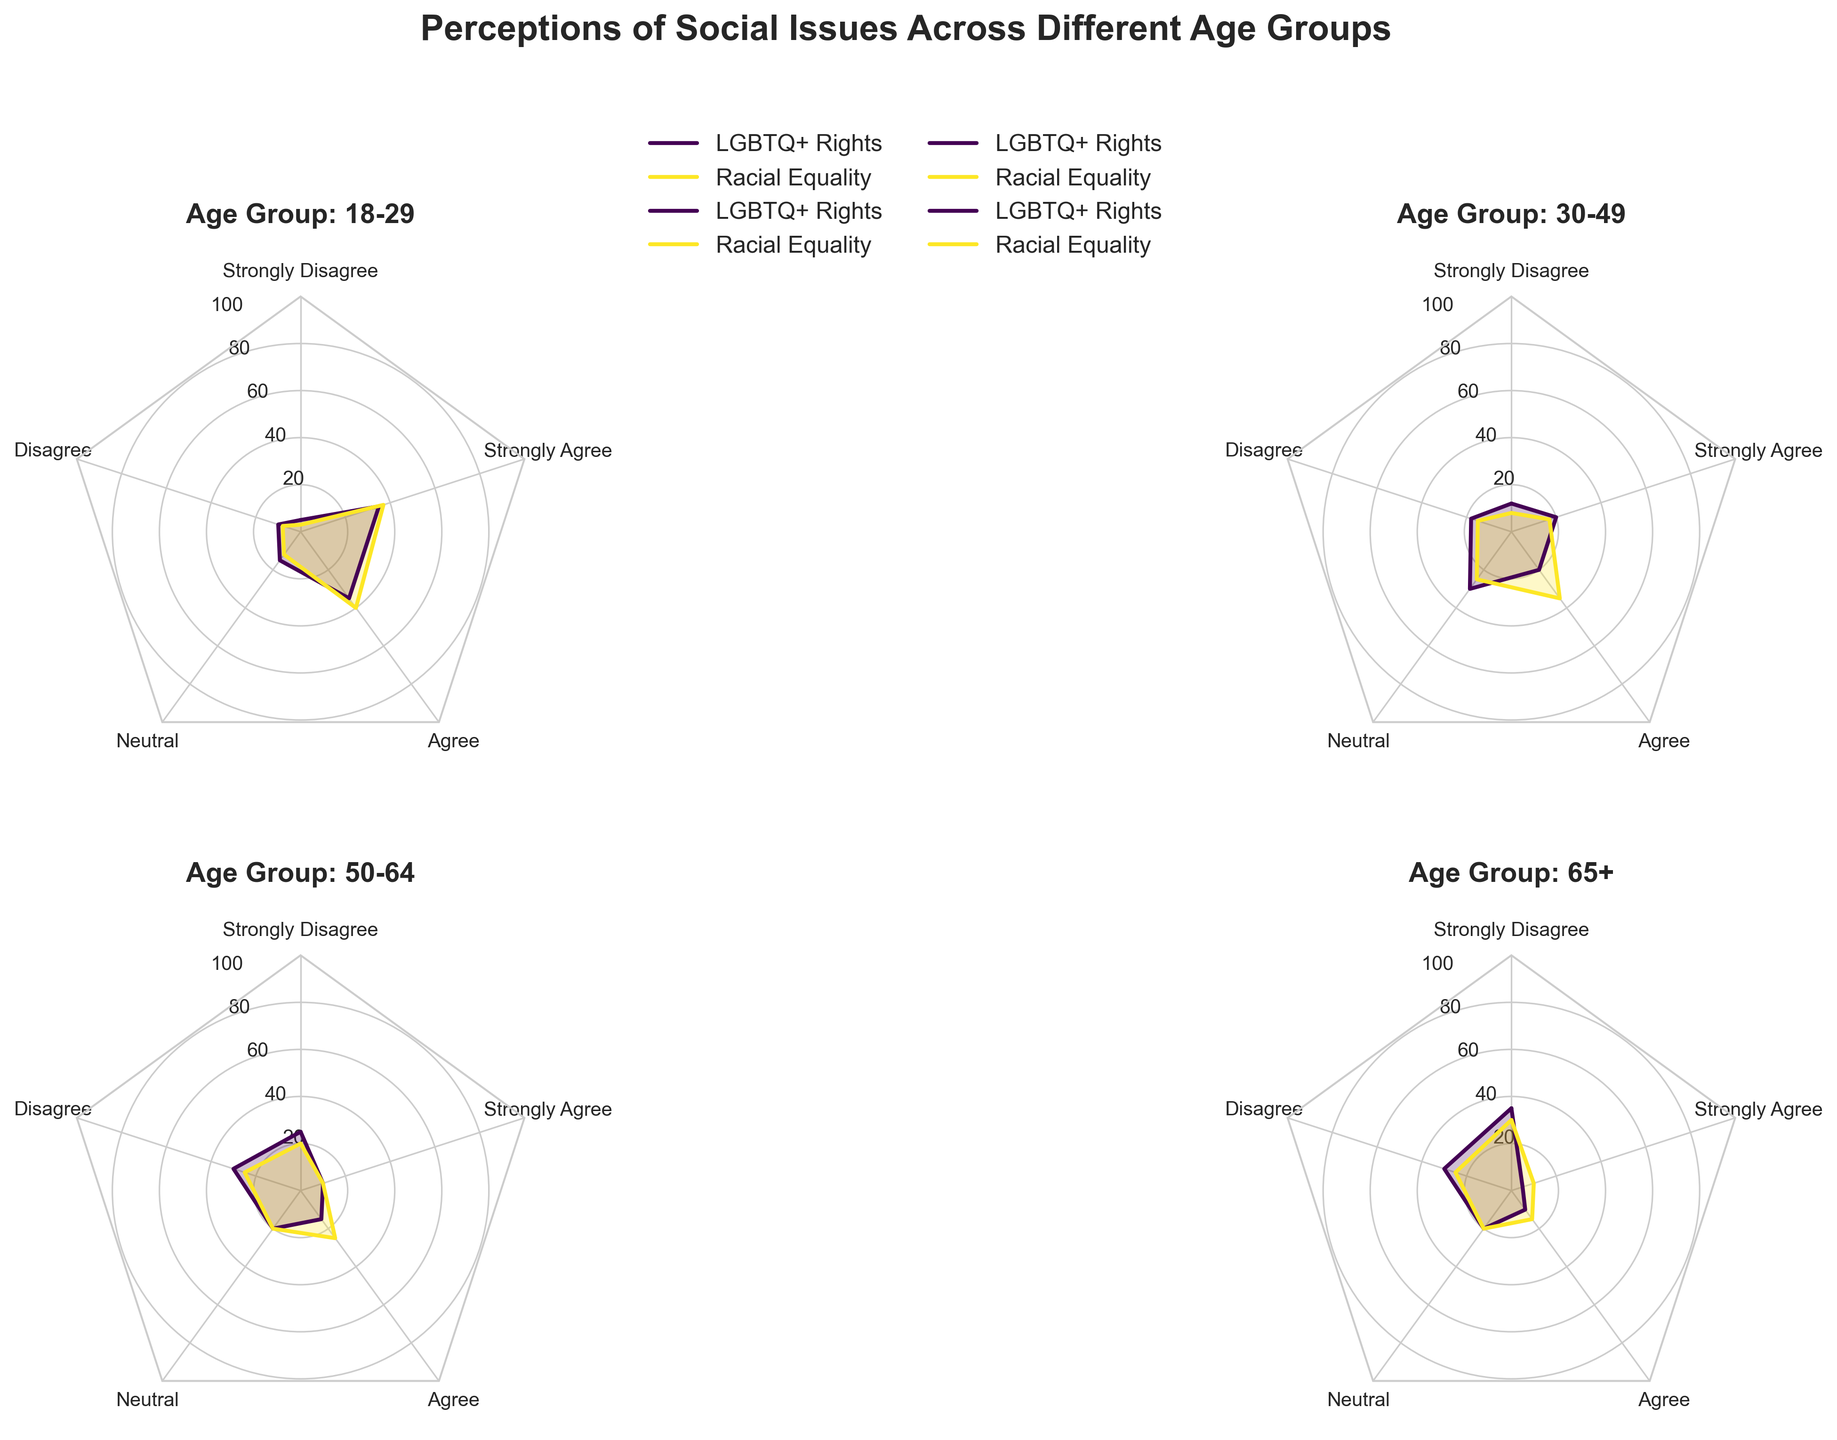What is the title of the figure? The title of the figure is displayed at the top of the plot and is typically in a larger font size compared to other text elements. It reads "Perceptions of Social Issues Across Different Age Groups".
Answer: Perceptions of Social Issues Across Different Age Groups Which social issue does the 18-29 age group agree with the most? To determine the social issue that the 18-29 age group agrees with the most, we need to look at the radar chart for this age group and identify the social issue with the highest values in the "Agree" and "Strongly Agree" categories. According to the chart data, for the 18-29 age group, "Racial Equality" has the highest combined percentage in these categories (40% "Agree" and 37% "Strongly Agree").
Answer: Racial Equality How do the perceptions of LGBTQ+ rights between the 30-49 and 50-64 age groups compare? To compare the perceptions of LGBTQ+ rights between the 30-49 and 50-64 age groups, observe the corresponding radar charts for each age group. The 30-49 age group has 12% "Strongly Disagree", 18% "Disagree", 30% "Neutral", 20% "Agree", and 20% "Strongly Agree". In contrast, the 50-64 age group has 25% "Strongly Disagree", 30% "Disagree", 20% "Neutral", 15% "Agree", and 10% "Strongly Agree". The older age group (50-64) is more in disagreement with LGBTQ+ rights compared to the younger (30-49) age group.
Answer: The 50-64 age group disagrees more What percentage of the 65+ age group strongly disagrees with LGBTQ+ rights? In the radar chart, the point corresponding to "Strongly Disagree" for LGBTQ+ rights within the 65+ age group is observed. According to the provided data for the 65+ age group, 35% strongly disagree with LGBTQ+ rights.
Answer: 35% Which age group shows the most balanced perception of LGBTQ+ rights (most similar values across categories)? To determine which age group shows the most balanced perception of LGBTQ+ rights, we need to find the group with the most similar values across all five categories for LGBTQ+ rights. Based on the radar chart data, the 30-49 age group has values that are relatively close across categories (12%, 18%, 30%, 20%, and 20%), indicating a more balanced distribution compared to other age groups.
Answer: 30-49 Which age group has the highest percentage of neutral responses towards racial equality? To find the age group with the highest neutral responses towards racial equality, examine the radar charts and identify the "Neutral" category's percentage for racial equality for each age group. According to the data, the 30-49 age group has the highest percentage of neutral responses towards racial equality at 25%.
Answer: 30-49 